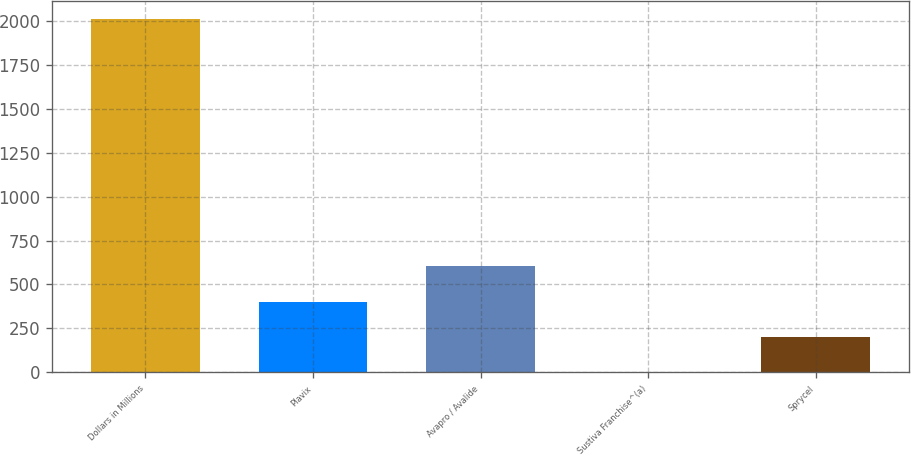Convert chart to OTSL. <chart><loc_0><loc_0><loc_500><loc_500><bar_chart><fcel>Dollars in Millions<fcel>Plavix<fcel>Avapro / Avalide<fcel>Sustiva Franchise^(a)<fcel>Sprycel<nl><fcel>2012<fcel>402.88<fcel>604.02<fcel>0.6<fcel>201.74<nl></chart> 